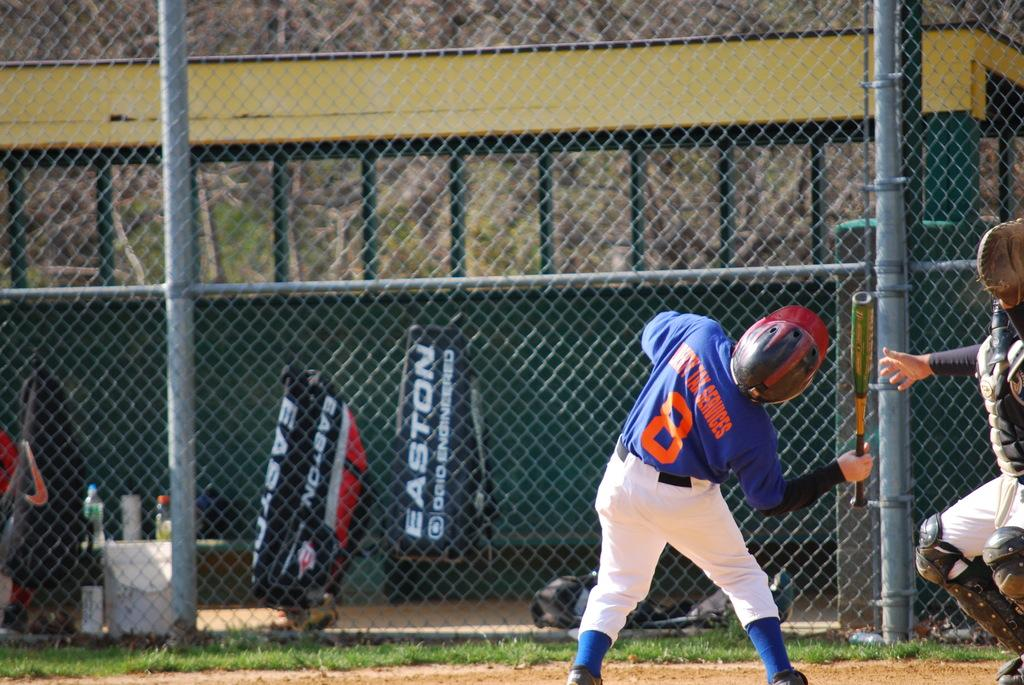Provide a one-sentence caption for the provided image. A batter whose number is 8 is ducking in the batter's box from a high pitch.. 